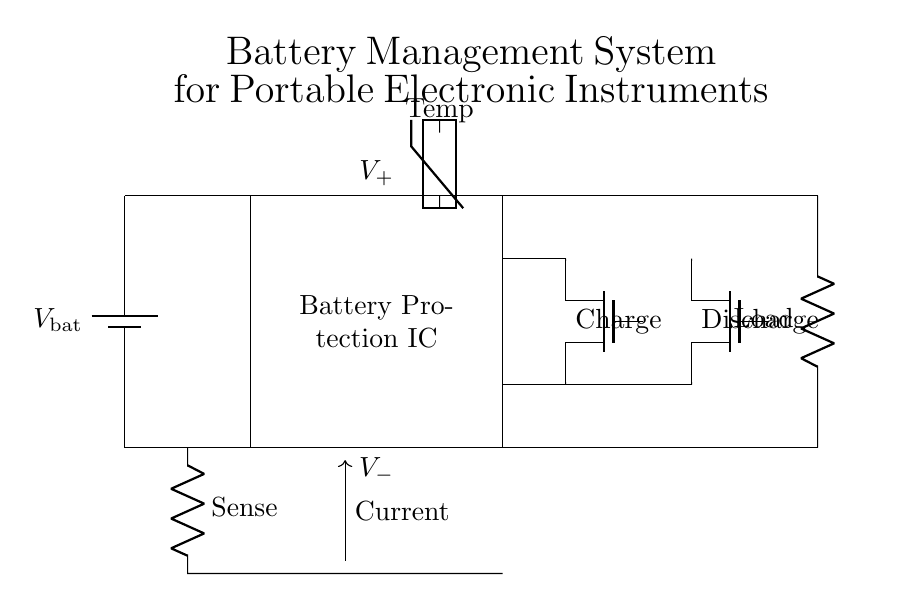What is the main component for battery protection in this circuit? The main component responsible for battery protection is identified as the 'Battery Protection IC' within the rectangular block, which manages the operation of the battery.
Answer: Battery Protection IC What type of switches are used for charge and discharge? The switches used for controlling charge and discharge are labeled as 'Tnmos', indicating they are n-channel MOSFETs. There are two such switches in the circuit.
Answer: Tnmos How is the current monitored in this system? The current is monitored by a 'Sense' resistor placed between two points in the circuit, allowing for current measurement to ensure proper function of the battery management system.
Answer: Sense What is the purpose of the thermistor in this circuit? The thermistor is used to monitor temperature, helping to protect the battery by ensuring it operates within safe thermal limits. This is vital for preventing overheating.
Answer: Temperature monitoring What are the voltage levels indicated in the circuit? The voltage levels are indicated with 'V+' at the positive side of the battery, and 'V-' at the negative side, showing the potential difference across the battery.
Answer: V+ and V- How many connections does the Battery Protection IC make to the MOSFET switches? The Battery Protection IC makes three connections to the two MOSFET switches: one for charge and one for discharge on each switch, totaling three physical connections.
Answer: Three connections 